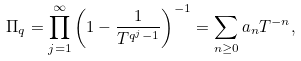Convert formula to latex. <formula><loc_0><loc_0><loc_500><loc_500>\Pi _ { q } = \prod _ { j = 1 } ^ { \infty } { \left ( 1 - \frac { 1 } { T ^ { q ^ { j } - 1 } } \right ) ^ { - 1 } } = \sum _ { n \geq 0 } { a _ { n } T ^ { - n } } ,</formula> 